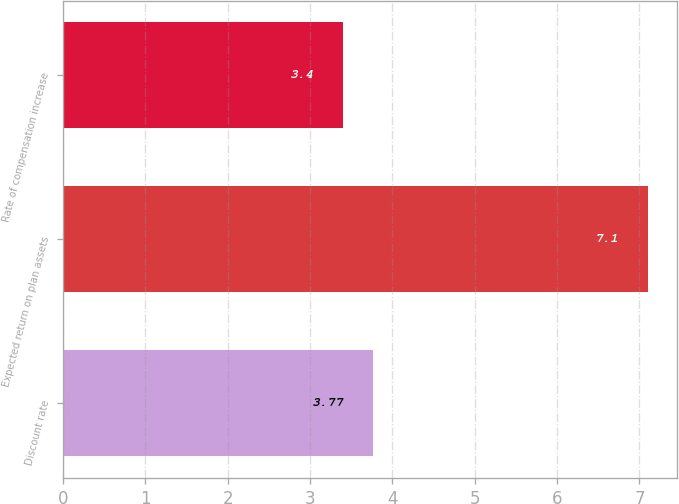Convert chart. <chart><loc_0><loc_0><loc_500><loc_500><bar_chart><fcel>Discount rate<fcel>Expected return on plan assets<fcel>Rate of compensation increase<nl><fcel>3.77<fcel>7.1<fcel>3.4<nl></chart> 